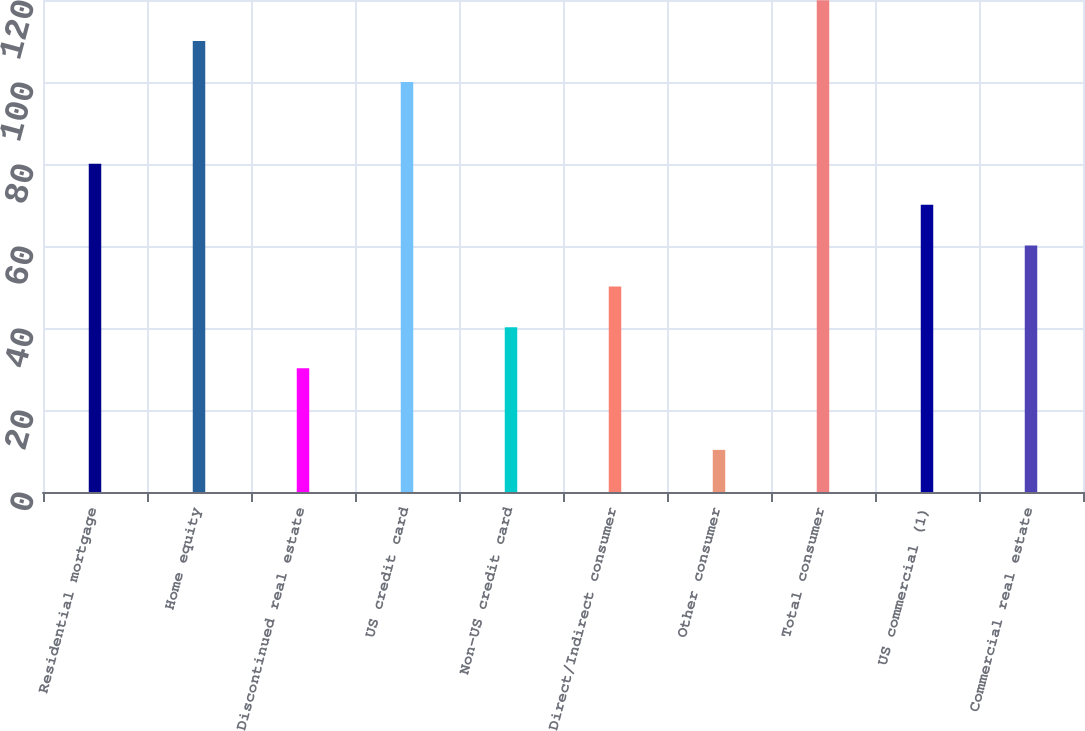Convert chart to OTSL. <chart><loc_0><loc_0><loc_500><loc_500><bar_chart><fcel>Residential mortgage<fcel>Home equity<fcel>Discontinued real estate<fcel>US credit card<fcel>Non-US credit card<fcel>Direct/Indirect consumer<fcel>Other consumer<fcel>Total consumer<fcel>US commercial (1)<fcel>Commercial real estate<nl><fcel>80.06<fcel>109.97<fcel>30.21<fcel>100<fcel>40.18<fcel>50.15<fcel>10.27<fcel>119.94<fcel>70.09<fcel>60.12<nl></chart> 